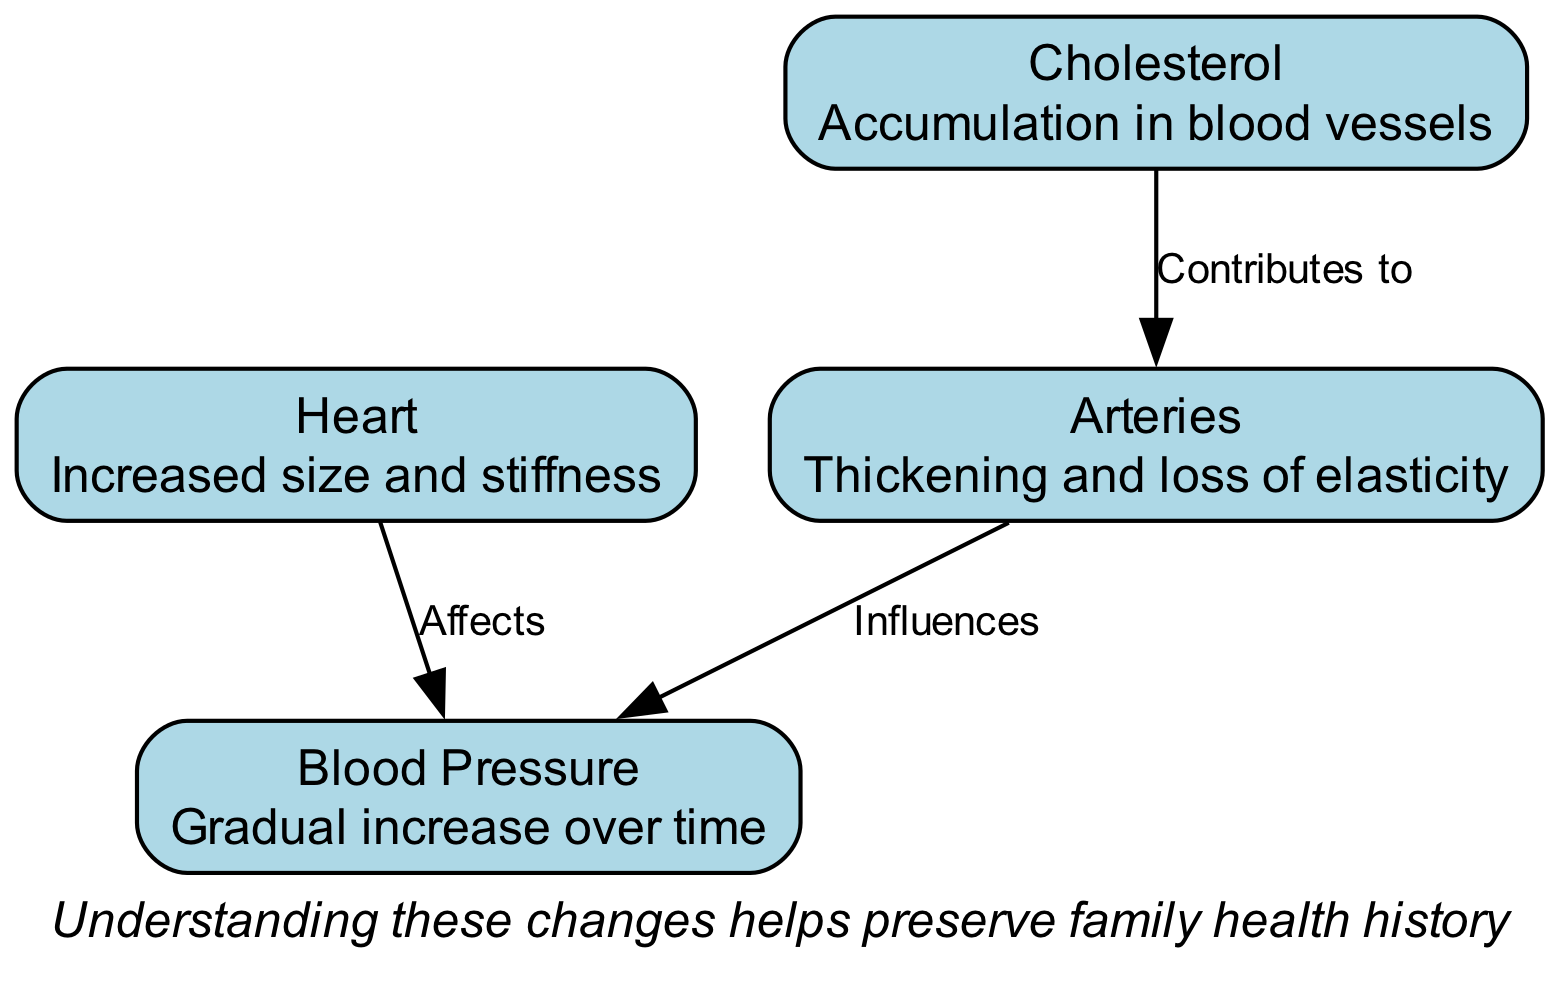What is the description of the heart? The diagram states that the heart has "Increased size and stiffness," which is clearly labeled under the heart node.
Answer: Increased size and stiffness How many nodes are present in the diagram? The diagram has four nodes: Heart, Arteries, Blood Pressure, and Cholesterol. This count can be obtained by simply counting the number of unique nodes listed.
Answer: 4 What does cholesterol accumulate in? According to the diagram, cholesterol accumulates in blood vessels, as indicated in the description for the cholesterol node.
Answer: Blood vessels What effect does the heart have? The diagram specifies that the heart "Affects" blood pressure, shown by the directed edge connecting the heart and blood pressure nodes, with the label "Affects."
Answer: Blood pressure Which node influences blood pressure? The diagram illustrates that the arteries "Influence" blood pressure, as seen from the edge that connects the arteries node to the blood pressure node.
Answer: Arteries What relationship exists between cholesterol and arteries? There is a relationship indicating that cholesterol "Contributes to" the condition of arteries, which is reflected by the directed edge from cholesterol to arteries labeled "Contributes to."
Answer: Contributes to What is one key takeaway from the annotations? The annotation positioned at the bottom of the diagram states, "Understanding these changes helps preserve family health history," highlighting the significance of the cardiovascular changes.
Answer: Helps preserve family health history Which node has a description mentioning loss of elasticity? The arteries node states "Thickening and loss of elasticity," which directly describes this change in the vessels as age progresses.
Answer: Arteries What does the edge labeled "Influences" connect? The edge labeled "Influences" connects arteries and blood pressure, indicating the effect of one on the other as shown in the diagram."
Answer: Arteries and blood pressure 